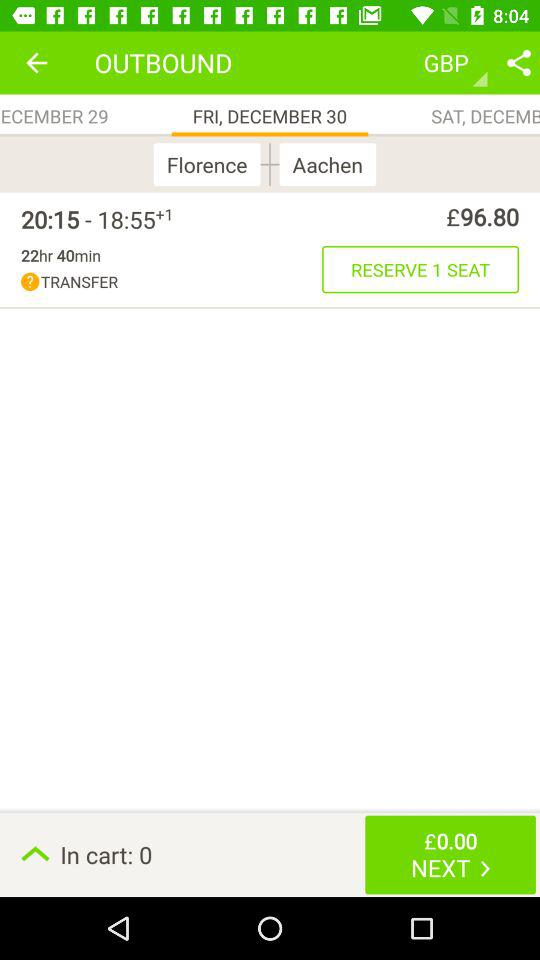What is the duration of the journey from Florence to Aachen? The duration of the journey is 22 hours and 40 minutes. 